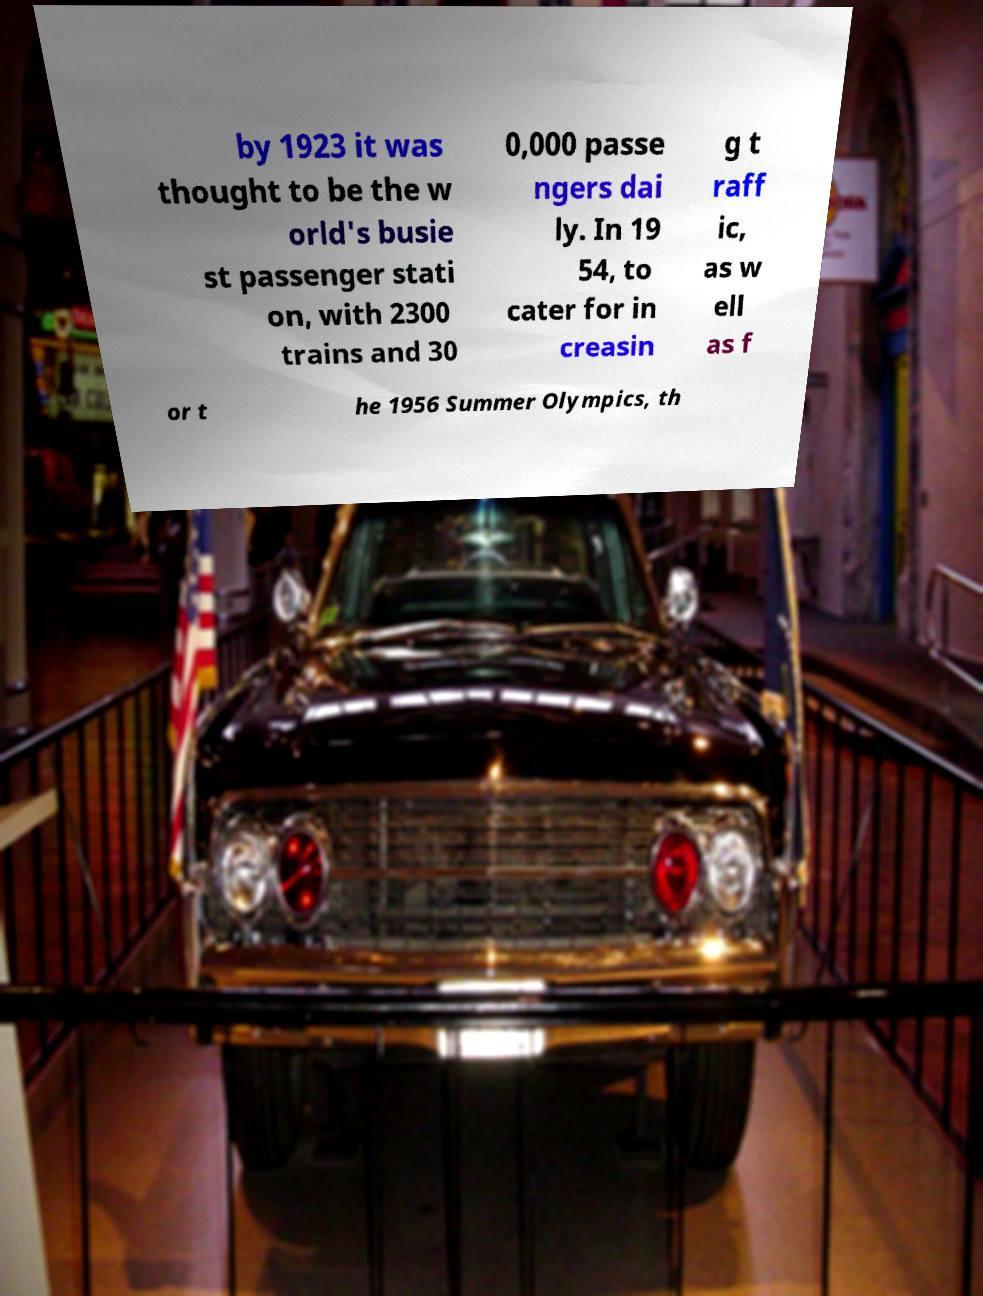Could you extract and type out the text from this image? by 1923 it was thought to be the w orld's busie st passenger stati on, with 2300 trains and 30 0,000 passe ngers dai ly. In 19 54, to cater for in creasin g t raff ic, as w ell as f or t he 1956 Summer Olympics, th 